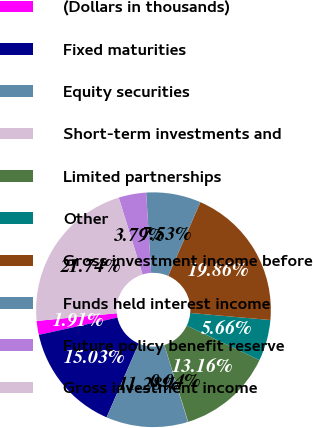Convert chart to OTSL. <chart><loc_0><loc_0><loc_500><loc_500><pie_chart><fcel>(Dollars in thousands)<fcel>Fixed maturities<fcel>Equity securities<fcel>Short-term investments and<fcel>Limited partnerships<fcel>Other<fcel>Gross investment income before<fcel>Funds held interest income<fcel>Future policy benefit reserve<fcel>Gross investment income<nl><fcel>1.91%<fcel>15.03%<fcel>11.28%<fcel>0.04%<fcel>13.16%<fcel>5.66%<fcel>19.86%<fcel>7.53%<fcel>3.79%<fcel>21.74%<nl></chart> 